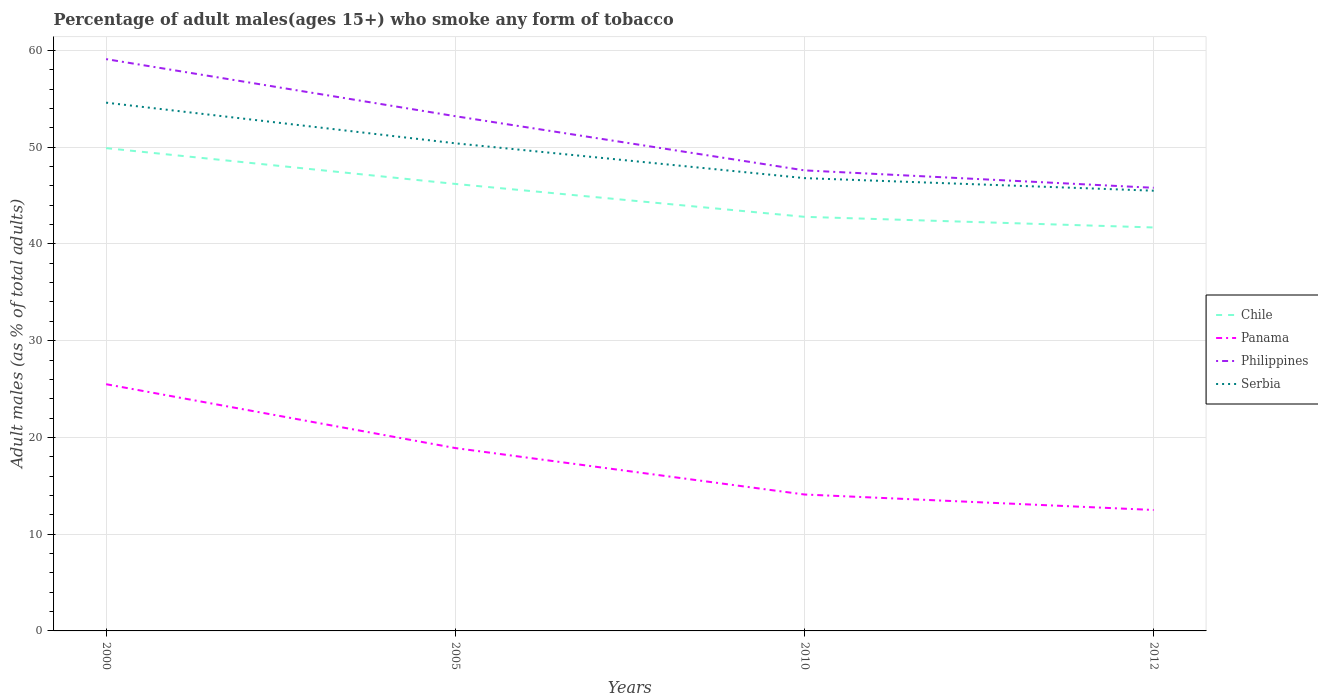How many different coloured lines are there?
Keep it short and to the point. 4. Is the number of lines equal to the number of legend labels?
Your response must be concise. Yes. Across all years, what is the maximum percentage of adult males who smoke in Serbia?
Offer a terse response. 45.5. In which year was the percentage of adult males who smoke in Chile maximum?
Your answer should be very brief. 2012. What is the total percentage of adult males who smoke in Serbia in the graph?
Keep it short and to the point. 9.1. What is the difference between the highest and the second highest percentage of adult males who smoke in Chile?
Offer a terse response. 8.2. Is the percentage of adult males who smoke in Panama strictly greater than the percentage of adult males who smoke in Chile over the years?
Your answer should be compact. Yes. How many lines are there?
Keep it short and to the point. 4. How many years are there in the graph?
Your answer should be compact. 4. Are the values on the major ticks of Y-axis written in scientific E-notation?
Ensure brevity in your answer.  No. Does the graph contain grids?
Your response must be concise. Yes. Where does the legend appear in the graph?
Your answer should be very brief. Center right. What is the title of the graph?
Provide a succinct answer. Percentage of adult males(ages 15+) who smoke any form of tobacco. What is the label or title of the X-axis?
Provide a succinct answer. Years. What is the label or title of the Y-axis?
Ensure brevity in your answer.  Adult males (as % of total adults). What is the Adult males (as % of total adults) of Chile in 2000?
Your answer should be compact. 49.9. What is the Adult males (as % of total adults) in Panama in 2000?
Your answer should be very brief. 25.5. What is the Adult males (as % of total adults) in Philippines in 2000?
Make the answer very short. 59.1. What is the Adult males (as % of total adults) of Serbia in 2000?
Provide a short and direct response. 54.6. What is the Adult males (as % of total adults) in Chile in 2005?
Keep it short and to the point. 46.2. What is the Adult males (as % of total adults) in Philippines in 2005?
Your response must be concise. 53.2. What is the Adult males (as % of total adults) in Serbia in 2005?
Keep it short and to the point. 50.4. What is the Adult males (as % of total adults) of Chile in 2010?
Keep it short and to the point. 42.8. What is the Adult males (as % of total adults) in Philippines in 2010?
Provide a short and direct response. 47.6. What is the Adult males (as % of total adults) in Serbia in 2010?
Give a very brief answer. 46.8. What is the Adult males (as % of total adults) in Chile in 2012?
Your answer should be compact. 41.7. What is the Adult males (as % of total adults) in Philippines in 2012?
Offer a very short reply. 45.8. What is the Adult males (as % of total adults) of Serbia in 2012?
Offer a very short reply. 45.5. Across all years, what is the maximum Adult males (as % of total adults) in Chile?
Your answer should be very brief. 49.9. Across all years, what is the maximum Adult males (as % of total adults) of Panama?
Provide a succinct answer. 25.5. Across all years, what is the maximum Adult males (as % of total adults) of Philippines?
Your answer should be very brief. 59.1. Across all years, what is the maximum Adult males (as % of total adults) in Serbia?
Make the answer very short. 54.6. Across all years, what is the minimum Adult males (as % of total adults) of Chile?
Give a very brief answer. 41.7. Across all years, what is the minimum Adult males (as % of total adults) of Panama?
Offer a terse response. 12.5. Across all years, what is the minimum Adult males (as % of total adults) of Philippines?
Your response must be concise. 45.8. Across all years, what is the minimum Adult males (as % of total adults) of Serbia?
Give a very brief answer. 45.5. What is the total Adult males (as % of total adults) in Chile in the graph?
Offer a terse response. 180.6. What is the total Adult males (as % of total adults) of Panama in the graph?
Your answer should be very brief. 71. What is the total Adult males (as % of total adults) in Philippines in the graph?
Offer a terse response. 205.7. What is the total Adult males (as % of total adults) in Serbia in the graph?
Provide a succinct answer. 197.3. What is the difference between the Adult males (as % of total adults) of Chile in 2000 and that in 2005?
Your answer should be compact. 3.7. What is the difference between the Adult males (as % of total adults) in Philippines in 2000 and that in 2005?
Offer a very short reply. 5.9. What is the difference between the Adult males (as % of total adults) in Chile in 2000 and that in 2012?
Give a very brief answer. 8.2. What is the difference between the Adult males (as % of total adults) in Panama in 2000 and that in 2012?
Make the answer very short. 13. What is the difference between the Adult males (as % of total adults) of Philippines in 2000 and that in 2012?
Offer a terse response. 13.3. What is the difference between the Adult males (as % of total adults) of Serbia in 2000 and that in 2012?
Keep it short and to the point. 9.1. What is the difference between the Adult males (as % of total adults) of Chile in 2005 and that in 2010?
Provide a succinct answer. 3.4. What is the difference between the Adult males (as % of total adults) in Panama in 2005 and that in 2010?
Make the answer very short. 4.8. What is the difference between the Adult males (as % of total adults) in Panama in 2005 and that in 2012?
Provide a succinct answer. 6.4. What is the difference between the Adult males (as % of total adults) of Philippines in 2005 and that in 2012?
Make the answer very short. 7.4. What is the difference between the Adult males (as % of total adults) in Chile in 2010 and that in 2012?
Offer a very short reply. 1.1. What is the difference between the Adult males (as % of total adults) of Panama in 2010 and that in 2012?
Provide a succinct answer. 1.6. What is the difference between the Adult males (as % of total adults) in Philippines in 2010 and that in 2012?
Keep it short and to the point. 1.8. What is the difference between the Adult males (as % of total adults) of Serbia in 2010 and that in 2012?
Your response must be concise. 1.3. What is the difference between the Adult males (as % of total adults) in Chile in 2000 and the Adult males (as % of total adults) in Panama in 2005?
Give a very brief answer. 31. What is the difference between the Adult males (as % of total adults) of Chile in 2000 and the Adult males (as % of total adults) of Serbia in 2005?
Offer a very short reply. -0.5. What is the difference between the Adult males (as % of total adults) in Panama in 2000 and the Adult males (as % of total adults) in Philippines in 2005?
Give a very brief answer. -27.7. What is the difference between the Adult males (as % of total adults) of Panama in 2000 and the Adult males (as % of total adults) of Serbia in 2005?
Give a very brief answer. -24.9. What is the difference between the Adult males (as % of total adults) in Chile in 2000 and the Adult males (as % of total adults) in Panama in 2010?
Give a very brief answer. 35.8. What is the difference between the Adult males (as % of total adults) of Chile in 2000 and the Adult males (as % of total adults) of Serbia in 2010?
Ensure brevity in your answer.  3.1. What is the difference between the Adult males (as % of total adults) in Panama in 2000 and the Adult males (as % of total adults) in Philippines in 2010?
Offer a terse response. -22.1. What is the difference between the Adult males (as % of total adults) in Panama in 2000 and the Adult males (as % of total adults) in Serbia in 2010?
Offer a very short reply. -21.3. What is the difference between the Adult males (as % of total adults) of Chile in 2000 and the Adult males (as % of total adults) of Panama in 2012?
Your answer should be compact. 37.4. What is the difference between the Adult males (as % of total adults) of Chile in 2000 and the Adult males (as % of total adults) of Philippines in 2012?
Ensure brevity in your answer.  4.1. What is the difference between the Adult males (as % of total adults) of Chile in 2000 and the Adult males (as % of total adults) of Serbia in 2012?
Give a very brief answer. 4.4. What is the difference between the Adult males (as % of total adults) of Panama in 2000 and the Adult males (as % of total adults) of Philippines in 2012?
Your answer should be very brief. -20.3. What is the difference between the Adult males (as % of total adults) in Chile in 2005 and the Adult males (as % of total adults) in Panama in 2010?
Your response must be concise. 32.1. What is the difference between the Adult males (as % of total adults) in Chile in 2005 and the Adult males (as % of total adults) in Serbia in 2010?
Your answer should be compact. -0.6. What is the difference between the Adult males (as % of total adults) of Panama in 2005 and the Adult males (as % of total adults) of Philippines in 2010?
Ensure brevity in your answer.  -28.7. What is the difference between the Adult males (as % of total adults) of Panama in 2005 and the Adult males (as % of total adults) of Serbia in 2010?
Provide a short and direct response. -27.9. What is the difference between the Adult males (as % of total adults) in Philippines in 2005 and the Adult males (as % of total adults) in Serbia in 2010?
Offer a terse response. 6.4. What is the difference between the Adult males (as % of total adults) of Chile in 2005 and the Adult males (as % of total adults) of Panama in 2012?
Make the answer very short. 33.7. What is the difference between the Adult males (as % of total adults) of Panama in 2005 and the Adult males (as % of total adults) of Philippines in 2012?
Give a very brief answer. -26.9. What is the difference between the Adult males (as % of total adults) of Panama in 2005 and the Adult males (as % of total adults) of Serbia in 2012?
Give a very brief answer. -26.6. What is the difference between the Adult males (as % of total adults) of Philippines in 2005 and the Adult males (as % of total adults) of Serbia in 2012?
Give a very brief answer. 7.7. What is the difference between the Adult males (as % of total adults) of Chile in 2010 and the Adult males (as % of total adults) of Panama in 2012?
Your answer should be very brief. 30.3. What is the difference between the Adult males (as % of total adults) of Chile in 2010 and the Adult males (as % of total adults) of Philippines in 2012?
Ensure brevity in your answer.  -3. What is the difference between the Adult males (as % of total adults) of Chile in 2010 and the Adult males (as % of total adults) of Serbia in 2012?
Your response must be concise. -2.7. What is the difference between the Adult males (as % of total adults) of Panama in 2010 and the Adult males (as % of total adults) of Philippines in 2012?
Keep it short and to the point. -31.7. What is the difference between the Adult males (as % of total adults) in Panama in 2010 and the Adult males (as % of total adults) in Serbia in 2012?
Your response must be concise. -31.4. What is the average Adult males (as % of total adults) in Chile per year?
Your response must be concise. 45.15. What is the average Adult males (as % of total adults) in Panama per year?
Your answer should be compact. 17.75. What is the average Adult males (as % of total adults) of Philippines per year?
Your answer should be compact. 51.42. What is the average Adult males (as % of total adults) of Serbia per year?
Provide a succinct answer. 49.33. In the year 2000, what is the difference between the Adult males (as % of total adults) of Chile and Adult males (as % of total adults) of Panama?
Provide a succinct answer. 24.4. In the year 2000, what is the difference between the Adult males (as % of total adults) in Panama and Adult males (as % of total adults) in Philippines?
Offer a very short reply. -33.6. In the year 2000, what is the difference between the Adult males (as % of total adults) of Panama and Adult males (as % of total adults) of Serbia?
Offer a terse response. -29.1. In the year 2005, what is the difference between the Adult males (as % of total adults) in Chile and Adult males (as % of total adults) in Panama?
Keep it short and to the point. 27.3. In the year 2005, what is the difference between the Adult males (as % of total adults) of Panama and Adult males (as % of total adults) of Philippines?
Your answer should be very brief. -34.3. In the year 2005, what is the difference between the Adult males (as % of total adults) in Panama and Adult males (as % of total adults) in Serbia?
Provide a succinct answer. -31.5. In the year 2005, what is the difference between the Adult males (as % of total adults) in Philippines and Adult males (as % of total adults) in Serbia?
Give a very brief answer. 2.8. In the year 2010, what is the difference between the Adult males (as % of total adults) in Chile and Adult males (as % of total adults) in Panama?
Ensure brevity in your answer.  28.7. In the year 2010, what is the difference between the Adult males (as % of total adults) of Chile and Adult males (as % of total adults) of Philippines?
Offer a terse response. -4.8. In the year 2010, what is the difference between the Adult males (as % of total adults) of Chile and Adult males (as % of total adults) of Serbia?
Offer a very short reply. -4. In the year 2010, what is the difference between the Adult males (as % of total adults) of Panama and Adult males (as % of total adults) of Philippines?
Your answer should be very brief. -33.5. In the year 2010, what is the difference between the Adult males (as % of total adults) in Panama and Adult males (as % of total adults) in Serbia?
Your response must be concise. -32.7. In the year 2012, what is the difference between the Adult males (as % of total adults) of Chile and Adult males (as % of total adults) of Panama?
Your answer should be compact. 29.2. In the year 2012, what is the difference between the Adult males (as % of total adults) in Chile and Adult males (as % of total adults) in Serbia?
Ensure brevity in your answer.  -3.8. In the year 2012, what is the difference between the Adult males (as % of total adults) in Panama and Adult males (as % of total adults) in Philippines?
Offer a very short reply. -33.3. In the year 2012, what is the difference between the Adult males (as % of total adults) in Panama and Adult males (as % of total adults) in Serbia?
Your answer should be compact. -33. What is the ratio of the Adult males (as % of total adults) of Chile in 2000 to that in 2005?
Give a very brief answer. 1.08. What is the ratio of the Adult males (as % of total adults) of Panama in 2000 to that in 2005?
Offer a very short reply. 1.35. What is the ratio of the Adult males (as % of total adults) in Philippines in 2000 to that in 2005?
Your answer should be compact. 1.11. What is the ratio of the Adult males (as % of total adults) in Serbia in 2000 to that in 2005?
Your answer should be compact. 1.08. What is the ratio of the Adult males (as % of total adults) of Chile in 2000 to that in 2010?
Keep it short and to the point. 1.17. What is the ratio of the Adult males (as % of total adults) in Panama in 2000 to that in 2010?
Your answer should be very brief. 1.81. What is the ratio of the Adult males (as % of total adults) of Philippines in 2000 to that in 2010?
Make the answer very short. 1.24. What is the ratio of the Adult males (as % of total adults) of Serbia in 2000 to that in 2010?
Provide a short and direct response. 1.17. What is the ratio of the Adult males (as % of total adults) of Chile in 2000 to that in 2012?
Offer a terse response. 1.2. What is the ratio of the Adult males (as % of total adults) in Panama in 2000 to that in 2012?
Your answer should be compact. 2.04. What is the ratio of the Adult males (as % of total adults) of Philippines in 2000 to that in 2012?
Give a very brief answer. 1.29. What is the ratio of the Adult males (as % of total adults) in Chile in 2005 to that in 2010?
Your answer should be very brief. 1.08. What is the ratio of the Adult males (as % of total adults) of Panama in 2005 to that in 2010?
Provide a short and direct response. 1.34. What is the ratio of the Adult males (as % of total adults) in Philippines in 2005 to that in 2010?
Offer a terse response. 1.12. What is the ratio of the Adult males (as % of total adults) of Serbia in 2005 to that in 2010?
Your response must be concise. 1.08. What is the ratio of the Adult males (as % of total adults) of Chile in 2005 to that in 2012?
Ensure brevity in your answer.  1.11. What is the ratio of the Adult males (as % of total adults) of Panama in 2005 to that in 2012?
Provide a succinct answer. 1.51. What is the ratio of the Adult males (as % of total adults) in Philippines in 2005 to that in 2012?
Provide a succinct answer. 1.16. What is the ratio of the Adult males (as % of total adults) of Serbia in 2005 to that in 2012?
Your answer should be very brief. 1.11. What is the ratio of the Adult males (as % of total adults) in Chile in 2010 to that in 2012?
Make the answer very short. 1.03. What is the ratio of the Adult males (as % of total adults) in Panama in 2010 to that in 2012?
Offer a very short reply. 1.13. What is the ratio of the Adult males (as % of total adults) of Philippines in 2010 to that in 2012?
Make the answer very short. 1.04. What is the ratio of the Adult males (as % of total adults) of Serbia in 2010 to that in 2012?
Provide a short and direct response. 1.03. What is the difference between the highest and the second highest Adult males (as % of total adults) in Serbia?
Offer a very short reply. 4.2. What is the difference between the highest and the lowest Adult males (as % of total adults) of Panama?
Ensure brevity in your answer.  13. 